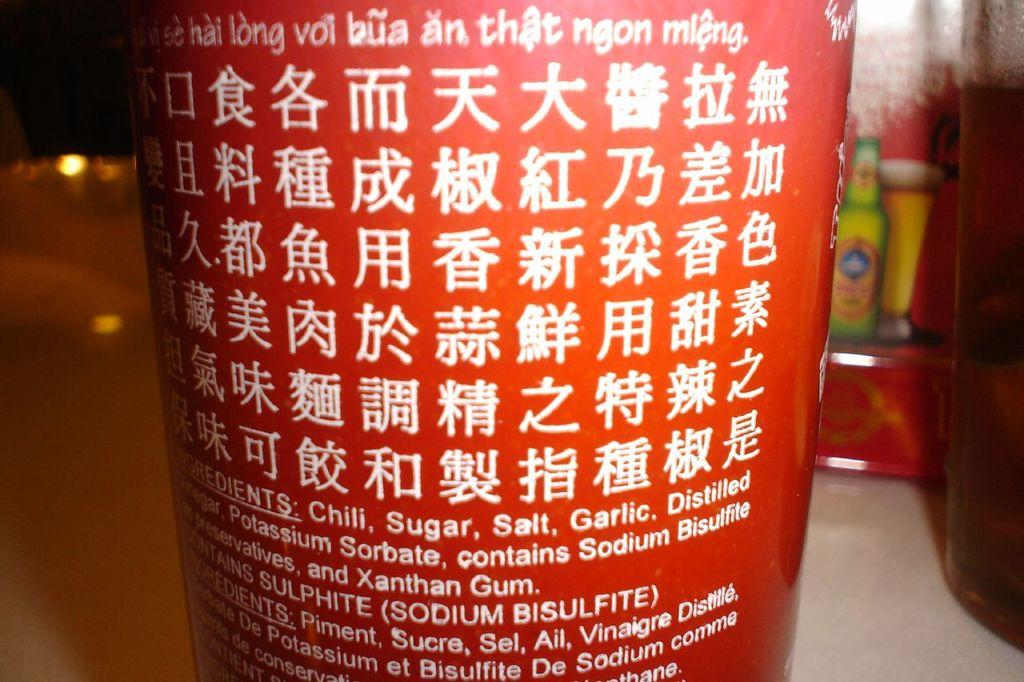What is the color of the object in the front of the image? The object in the front of the image is red in color. What is written on the red object? There is text written on the red object. What can be seen in the background of the image? There is a poster in the background of the image. What is located on the right side of the image? There is a glass on the right side of the image. Can you tell me how many monkeys are sitting on the glass in the image? There are no monkeys present in the image; it only features a red object, text, a poster, and a glass. 